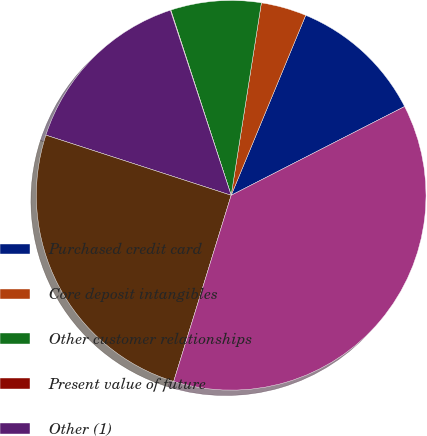<chart> <loc_0><loc_0><loc_500><loc_500><pie_chart><fcel>Purchased credit card<fcel>Core deposit intangibles<fcel>Other customer relationships<fcel>Present value of future<fcel>Other (1)<fcel>Intangible assets (excluding<fcel>Total intangible assets<nl><fcel>11.22%<fcel>3.77%<fcel>7.49%<fcel>0.04%<fcel>14.95%<fcel>25.23%<fcel>37.3%<nl></chart> 